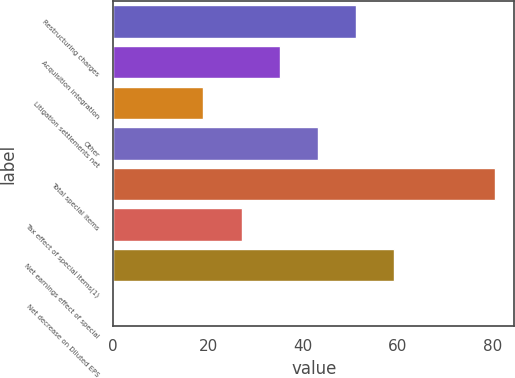Convert chart. <chart><loc_0><loc_0><loc_500><loc_500><bar_chart><fcel>Restructuring charges<fcel>Acquisition integration<fcel>Litigation settlements net<fcel>Other<fcel>Total special items<fcel>Tax effect of special items(1)<fcel>Net earnings effect of special<fcel>Net decrease on Diluted EPS<nl><fcel>51.16<fcel>35.08<fcel>19<fcel>43.12<fcel>80.5<fcel>27.04<fcel>59.2<fcel>0.14<nl></chart> 